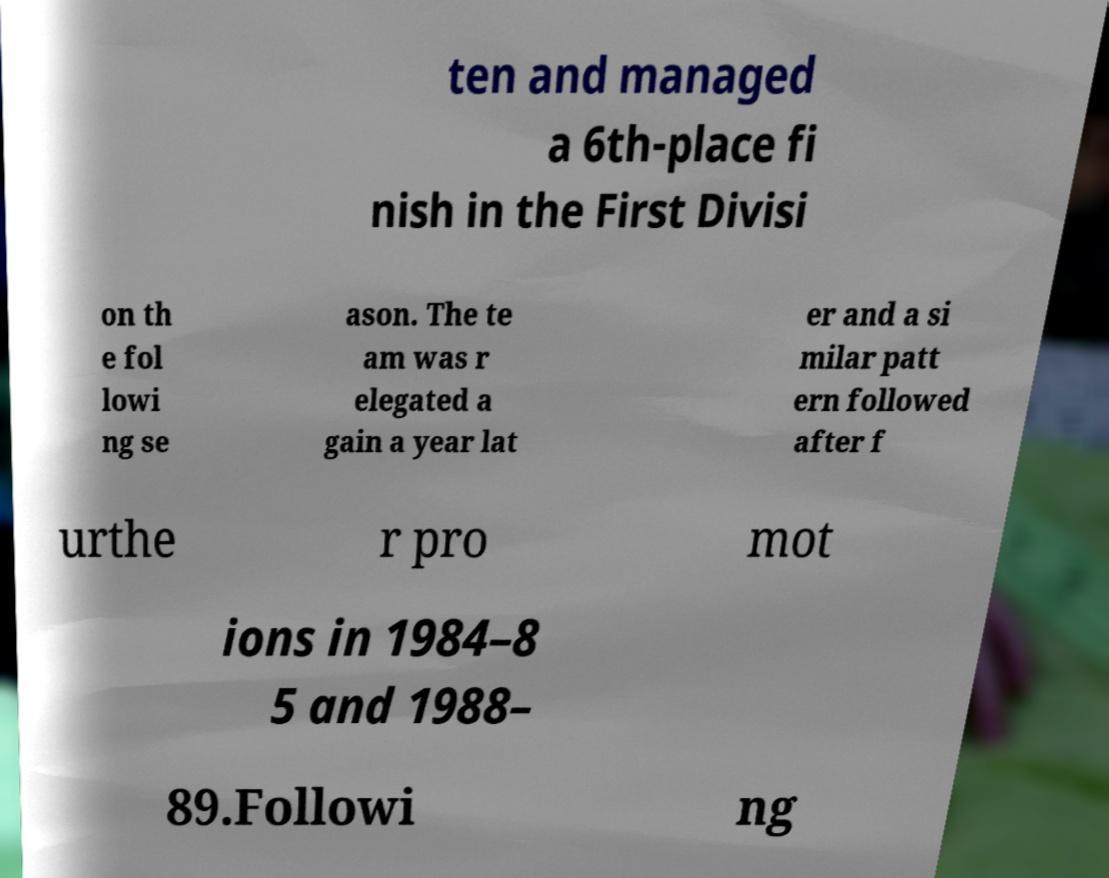Please read and relay the text visible in this image. What does it say? ten and managed a 6th-place fi nish in the First Divisi on th e fol lowi ng se ason. The te am was r elegated a gain a year lat er and a si milar patt ern followed after f urthe r pro mot ions in 1984–8 5 and 1988– 89.Followi ng 